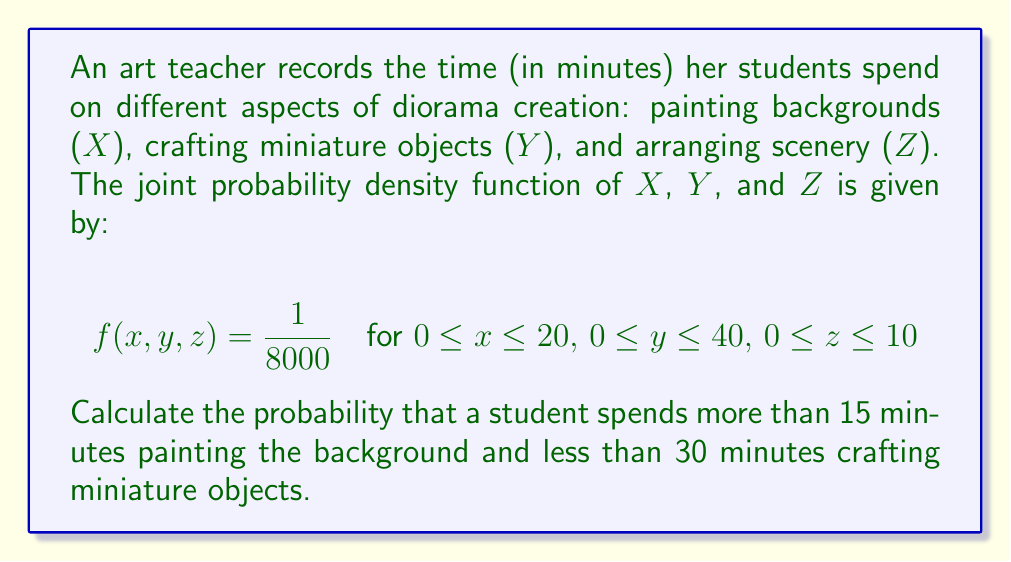Could you help me with this problem? To solve this problem, we need to integrate the joint probability density function over the specified region. Let's break it down step-by-step:

1) The region we're interested in is:
   $15 < x \leq 20$ (more than 15 minutes painting)
   $0 \leq y < 30$ (less than 30 minutes crafting)
   $0 \leq z \leq 10$ (full range for arranging)

2) We need to set up a triple integral:

   $$P(X > 15, Y < 30) = \int_{0}^{10} \int_{0}^{30} \int_{15}^{20} f(x,y,z) \, dx \, dy \, dz$$

3) Substitute the given probability density function:

   $$P(X > 15, Y < 30) = \int_{0}^{10} \int_{0}^{30} \int_{15}^{20} \frac{1}{8000} \, dx \, dy \, dz$$

4) Since the function is constant, we can simply calculate the volume of the region and multiply by $\frac{1}{8000}$:

   $$P(X > 15, Y < 30) = \frac{1}{8000} \cdot (20-15) \cdot 30 \cdot 10$$

5) Simplify:

   $$P(X > 15, Y < 30) = \frac{1}{8000} \cdot 5 \cdot 30 \cdot 10 = \frac{1500}{8000} = \frac{3}{16} = 0.1875$$

Thus, the probability is 0.1875 or 18.75%.
Answer: $\frac{3}{16}$ or 0.1875 